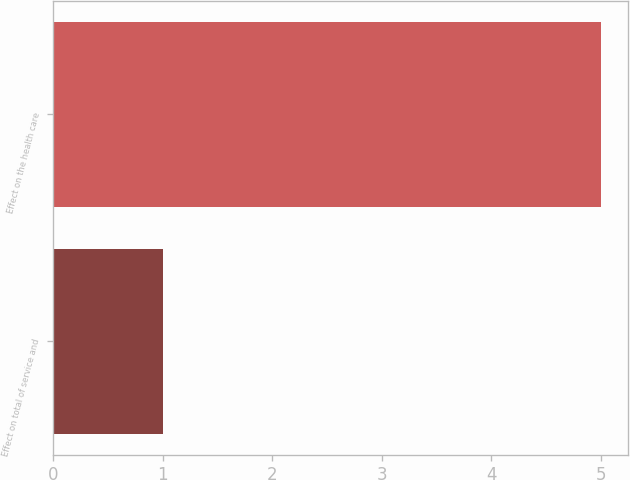Convert chart. <chart><loc_0><loc_0><loc_500><loc_500><bar_chart><fcel>Effect on total of service and<fcel>Effect on the health care<nl><fcel>1<fcel>5<nl></chart> 